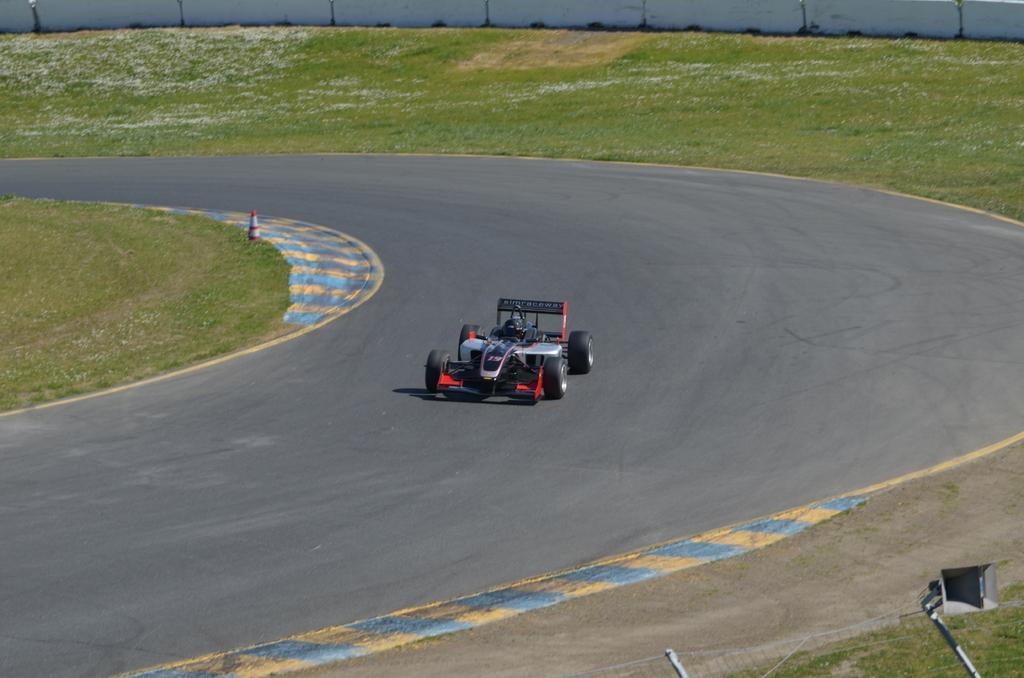Could you give a brief overview of what you see in this image? In this picture, we can see a sports car on the race track. On the behind the sport car there is a wall, grass and a cone barrier. In front of the car there is a fence. 